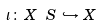Convert formula to latex. <formula><loc_0><loc_0><loc_500><loc_500>\iota \, \colon \, X \ S \, \hookrightarrow \, X</formula> 